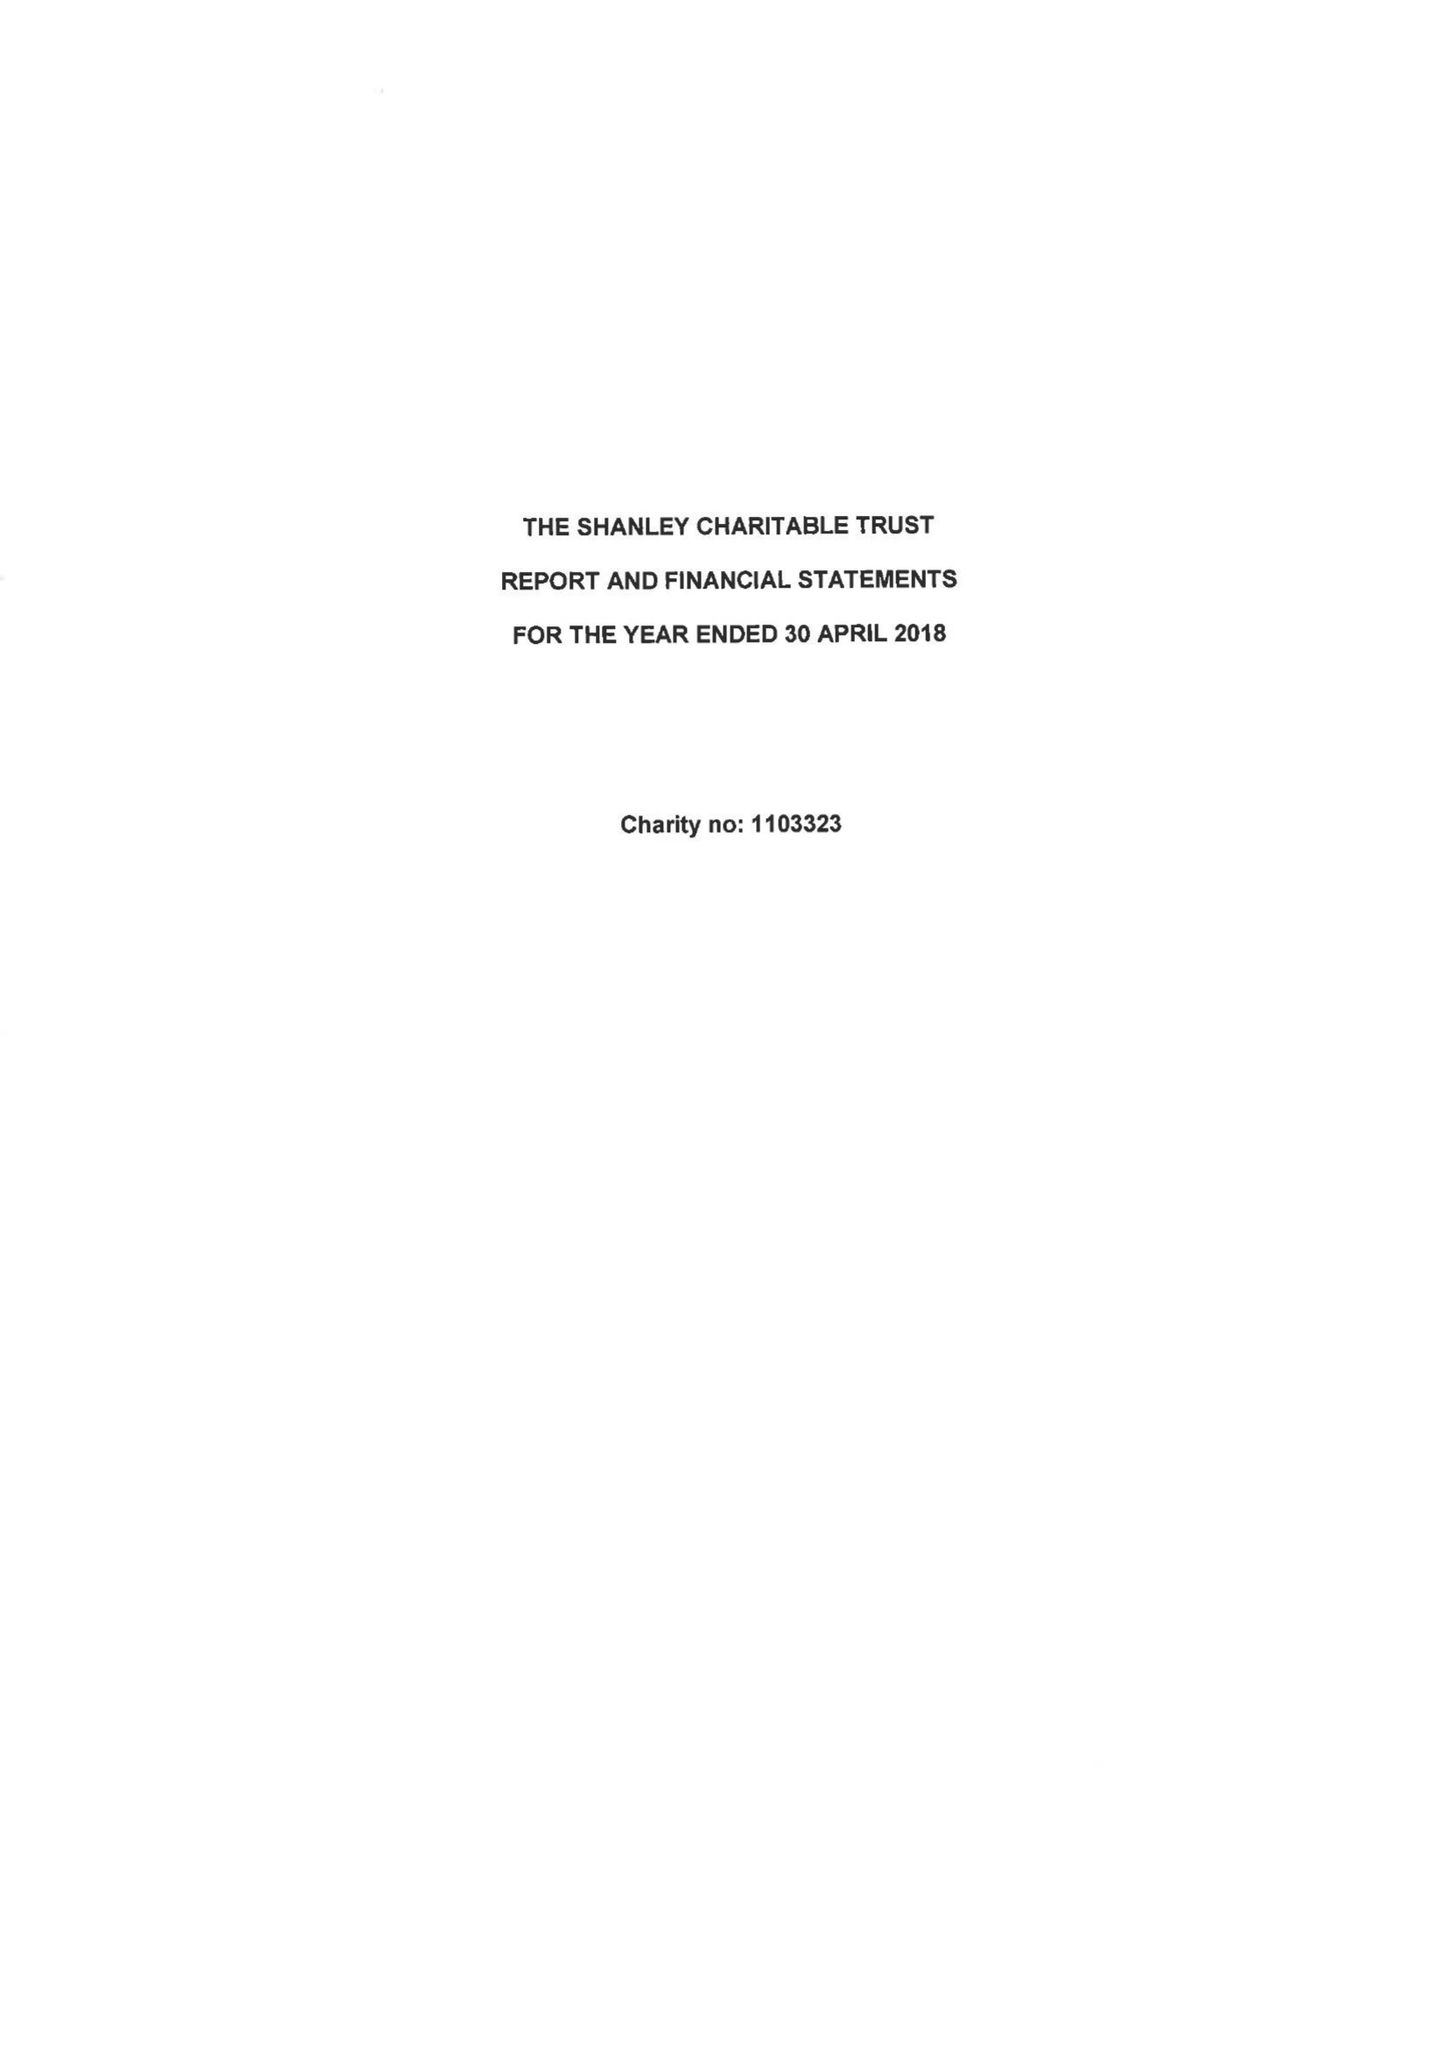What is the value for the address__postcode?
Answer the question using a single word or phrase. N12 7NY 